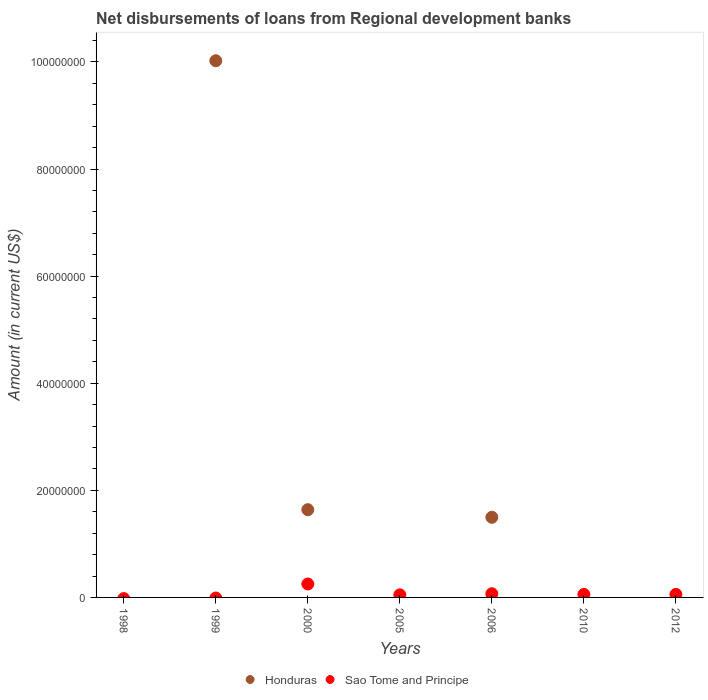Is the number of dotlines equal to the number of legend labels?
Offer a very short reply. No. What is the amount of disbursements of loans from regional development banks in Sao Tome and Principe in 2000?
Keep it short and to the point. 2.51e+06. Across all years, what is the maximum amount of disbursements of loans from regional development banks in Sao Tome and Principe?
Your answer should be very brief. 2.51e+06. Across all years, what is the minimum amount of disbursements of loans from regional development banks in Sao Tome and Principe?
Offer a terse response. 0. What is the total amount of disbursements of loans from regional development banks in Sao Tome and Principe in the graph?
Provide a short and direct response. 4.81e+06. What is the difference between the amount of disbursements of loans from regional development banks in Sao Tome and Principe in 2000 and that in 2005?
Your response must be concise. 2.02e+06. What is the difference between the amount of disbursements of loans from regional development banks in Honduras in 1999 and the amount of disbursements of loans from regional development banks in Sao Tome and Principe in 2012?
Your answer should be compact. 9.96e+07. What is the average amount of disbursements of loans from regional development banks in Honduras per year?
Provide a succinct answer. 1.88e+07. In the year 2000, what is the difference between the amount of disbursements of loans from regional development banks in Honduras and amount of disbursements of loans from regional development banks in Sao Tome and Principe?
Your response must be concise. 1.39e+07. What is the ratio of the amount of disbursements of loans from regional development banks in Sao Tome and Principe in 2005 to that in 2010?
Make the answer very short. 0.86. Is the difference between the amount of disbursements of loans from regional development banks in Honduras in 2000 and 2006 greater than the difference between the amount of disbursements of loans from regional development banks in Sao Tome and Principe in 2000 and 2006?
Offer a terse response. No. What is the difference between the highest and the second highest amount of disbursements of loans from regional development banks in Honduras?
Provide a succinct answer. 8.38e+07. What is the difference between the highest and the lowest amount of disbursements of loans from regional development banks in Honduras?
Provide a succinct answer. 1.00e+08. In how many years, is the amount of disbursements of loans from regional development banks in Sao Tome and Principe greater than the average amount of disbursements of loans from regional development banks in Sao Tome and Principe taken over all years?
Offer a very short reply. 1. Is the sum of the amount of disbursements of loans from regional development banks in Sao Tome and Principe in 2005 and 2012 greater than the maximum amount of disbursements of loans from regional development banks in Honduras across all years?
Keep it short and to the point. No. Is the amount of disbursements of loans from regional development banks in Honduras strictly greater than the amount of disbursements of loans from regional development banks in Sao Tome and Principe over the years?
Offer a terse response. No. What is the difference between two consecutive major ticks on the Y-axis?
Ensure brevity in your answer.  2.00e+07. What is the title of the graph?
Keep it short and to the point. Net disbursements of loans from Regional development banks. What is the label or title of the Y-axis?
Provide a short and direct response. Amount (in current US$). What is the Amount (in current US$) of Honduras in 1998?
Keep it short and to the point. 0. What is the Amount (in current US$) of Honduras in 1999?
Your answer should be very brief. 1.00e+08. What is the Amount (in current US$) of Sao Tome and Principe in 1999?
Provide a succinct answer. 0. What is the Amount (in current US$) of Honduras in 2000?
Offer a very short reply. 1.64e+07. What is the Amount (in current US$) in Sao Tome and Principe in 2000?
Your answer should be very brief. 2.51e+06. What is the Amount (in current US$) of Honduras in 2005?
Keep it short and to the point. 0. What is the Amount (in current US$) in Sao Tome and Principe in 2005?
Provide a short and direct response. 4.85e+05. What is the Amount (in current US$) in Honduras in 2006?
Give a very brief answer. 1.50e+07. What is the Amount (in current US$) of Sao Tome and Principe in 2006?
Offer a very short reply. 6.86e+05. What is the Amount (in current US$) in Sao Tome and Principe in 2010?
Give a very brief answer. 5.65e+05. What is the Amount (in current US$) of Honduras in 2012?
Make the answer very short. 0. What is the Amount (in current US$) in Sao Tome and Principe in 2012?
Keep it short and to the point. 5.65e+05. Across all years, what is the maximum Amount (in current US$) in Honduras?
Your answer should be compact. 1.00e+08. Across all years, what is the maximum Amount (in current US$) in Sao Tome and Principe?
Your response must be concise. 2.51e+06. What is the total Amount (in current US$) in Honduras in the graph?
Provide a succinct answer. 1.32e+08. What is the total Amount (in current US$) in Sao Tome and Principe in the graph?
Keep it short and to the point. 4.81e+06. What is the difference between the Amount (in current US$) of Honduras in 1999 and that in 2000?
Provide a succinct answer. 8.38e+07. What is the difference between the Amount (in current US$) in Honduras in 1999 and that in 2006?
Provide a succinct answer. 8.52e+07. What is the difference between the Amount (in current US$) of Sao Tome and Principe in 2000 and that in 2005?
Make the answer very short. 2.02e+06. What is the difference between the Amount (in current US$) in Honduras in 2000 and that in 2006?
Your answer should be very brief. 1.42e+06. What is the difference between the Amount (in current US$) of Sao Tome and Principe in 2000 and that in 2006?
Ensure brevity in your answer.  1.82e+06. What is the difference between the Amount (in current US$) of Sao Tome and Principe in 2000 and that in 2010?
Your answer should be very brief. 1.94e+06. What is the difference between the Amount (in current US$) in Sao Tome and Principe in 2000 and that in 2012?
Offer a terse response. 1.94e+06. What is the difference between the Amount (in current US$) of Sao Tome and Principe in 2005 and that in 2006?
Your answer should be very brief. -2.01e+05. What is the difference between the Amount (in current US$) in Sao Tome and Principe in 2005 and that in 2010?
Your response must be concise. -8.00e+04. What is the difference between the Amount (in current US$) of Sao Tome and Principe in 2006 and that in 2010?
Your answer should be compact. 1.21e+05. What is the difference between the Amount (in current US$) of Sao Tome and Principe in 2006 and that in 2012?
Provide a succinct answer. 1.21e+05. What is the difference between the Amount (in current US$) of Sao Tome and Principe in 2010 and that in 2012?
Offer a very short reply. 0. What is the difference between the Amount (in current US$) of Honduras in 1999 and the Amount (in current US$) of Sao Tome and Principe in 2000?
Keep it short and to the point. 9.77e+07. What is the difference between the Amount (in current US$) of Honduras in 1999 and the Amount (in current US$) of Sao Tome and Principe in 2005?
Your answer should be compact. 9.97e+07. What is the difference between the Amount (in current US$) in Honduras in 1999 and the Amount (in current US$) in Sao Tome and Principe in 2006?
Your answer should be compact. 9.95e+07. What is the difference between the Amount (in current US$) of Honduras in 1999 and the Amount (in current US$) of Sao Tome and Principe in 2010?
Your answer should be very brief. 9.96e+07. What is the difference between the Amount (in current US$) in Honduras in 1999 and the Amount (in current US$) in Sao Tome and Principe in 2012?
Your response must be concise. 9.96e+07. What is the difference between the Amount (in current US$) of Honduras in 2000 and the Amount (in current US$) of Sao Tome and Principe in 2005?
Your answer should be very brief. 1.59e+07. What is the difference between the Amount (in current US$) in Honduras in 2000 and the Amount (in current US$) in Sao Tome and Principe in 2006?
Your answer should be compact. 1.57e+07. What is the difference between the Amount (in current US$) in Honduras in 2000 and the Amount (in current US$) in Sao Tome and Principe in 2010?
Your response must be concise. 1.58e+07. What is the difference between the Amount (in current US$) in Honduras in 2000 and the Amount (in current US$) in Sao Tome and Principe in 2012?
Give a very brief answer. 1.58e+07. What is the difference between the Amount (in current US$) of Honduras in 2006 and the Amount (in current US$) of Sao Tome and Principe in 2010?
Your answer should be very brief. 1.44e+07. What is the difference between the Amount (in current US$) of Honduras in 2006 and the Amount (in current US$) of Sao Tome and Principe in 2012?
Your response must be concise. 1.44e+07. What is the average Amount (in current US$) in Honduras per year?
Ensure brevity in your answer.  1.88e+07. What is the average Amount (in current US$) in Sao Tome and Principe per year?
Give a very brief answer. 6.87e+05. In the year 2000, what is the difference between the Amount (in current US$) of Honduras and Amount (in current US$) of Sao Tome and Principe?
Keep it short and to the point. 1.39e+07. In the year 2006, what is the difference between the Amount (in current US$) of Honduras and Amount (in current US$) of Sao Tome and Principe?
Make the answer very short. 1.43e+07. What is the ratio of the Amount (in current US$) of Honduras in 1999 to that in 2000?
Offer a terse response. 6.12. What is the ratio of the Amount (in current US$) in Honduras in 1999 to that in 2006?
Provide a short and direct response. 6.7. What is the ratio of the Amount (in current US$) in Sao Tome and Principe in 2000 to that in 2005?
Offer a terse response. 5.17. What is the ratio of the Amount (in current US$) in Honduras in 2000 to that in 2006?
Ensure brevity in your answer.  1.09. What is the ratio of the Amount (in current US$) of Sao Tome and Principe in 2000 to that in 2006?
Offer a terse response. 3.66. What is the ratio of the Amount (in current US$) in Sao Tome and Principe in 2000 to that in 2010?
Your response must be concise. 4.44. What is the ratio of the Amount (in current US$) of Sao Tome and Principe in 2000 to that in 2012?
Offer a terse response. 4.44. What is the ratio of the Amount (in current US$) of Sao Tome and Principe in 2005 to that in 2006?
Your answer should be very brief. 0.71. What is the ratio of the Amount (in current US$) of Sao Tome and Principe in 2005 to that in 2010?
Give a very brief answer. 0.86. What is the ratio of the Amount (in current US$) in Sao Tome and Principe in 2005 to that in 2012?
Your response must be concise. 0.86. What is the ratio of the Amount (in current US$) of Sao Tome and Principe in 2006 to that in 2010?
Make the answer very short. 1.21. What is the ratio of the Amount (in current US$) of Sao Tome and Principe in 2006 to that in 2012?
Your answer should be compact. 1.21. What is the difference between the highest and the second highest Amount (in current US$) in Honduras?
Give a very brief answer. 8.38e+07. What is the difference between the highest and the second highest Amount (in current US$) in Sao Tome and Principe?
Provide a short and direct response. 1.82e+06. What is the difference between the highest and the lowest Amount (in current US$) of Honduras?
Your answer should be compact. 1.00e+08. What is the difference between the highest and the lowest Amount (in current US$) of Sao Tome and Principe?
Your answer should be very brief. 2.51e+06. 